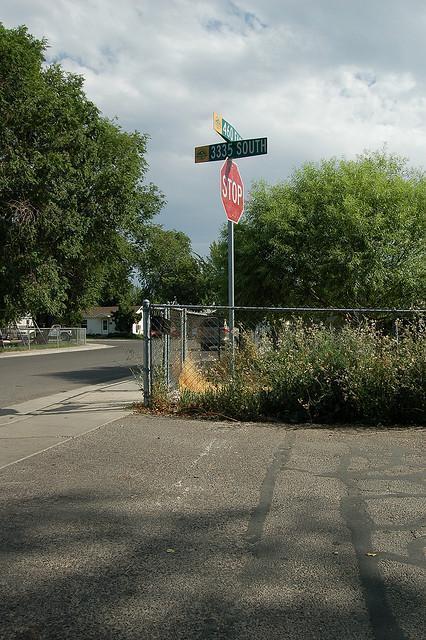How many bikes are here?
Give a very brief answer. 0. 